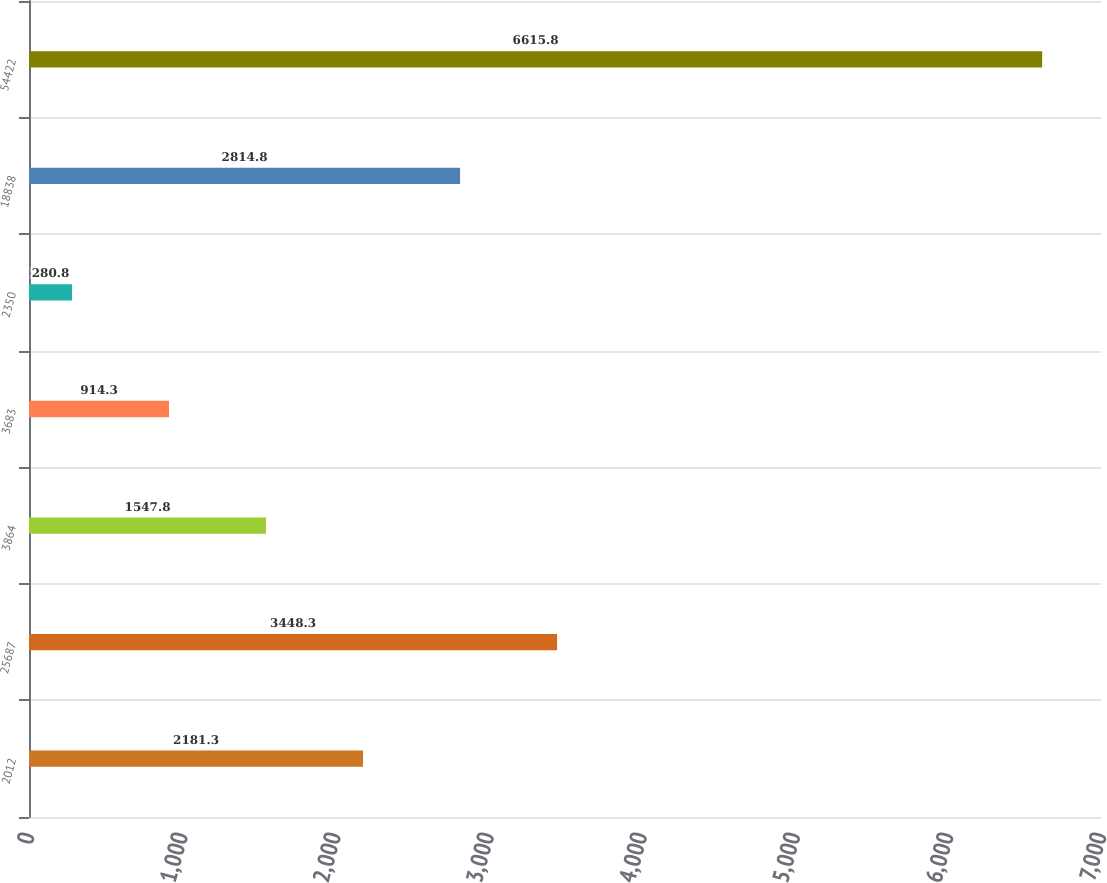Convert chart. <chart><loc_0><loc_0><loc_500><loc_500><bar_chart><fcel>2012<fcel>25687<fcel>3864<fcel>3683<fcel>2350<fcel>18838<fcel>54422<nl><fcel>2181.3<fcel>3448.3<fcel>1547.8<fcel>914.3<fcel>280.8<fcel>2814.8<fcel>6615.8<nl></chart> 